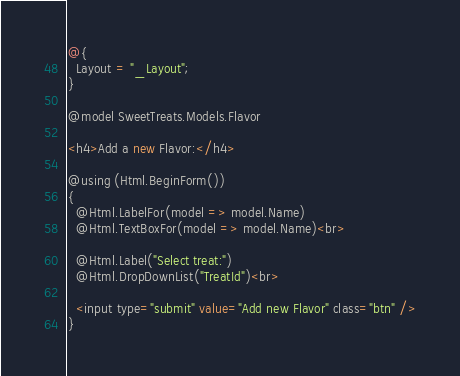<code> <loc_0><loc_0><loc_500><loc_500><_C#_>@{
  Layout = "_Layout";
}

@model SweetTreats.Models.Flavor

<h4>Add a new Flavor:</h4>

@using (Html.BeginForm())
{
  @Html.LabelFor(model => model.Name)
  @Html.TextBoxFor(model => model.Name)<br>

  @Html.Label("Select treat:")
  @Html.DropDownList("TreatId")<br>

  <input type="submit" value="Add new Flavor" class="btn" />
}</code> 